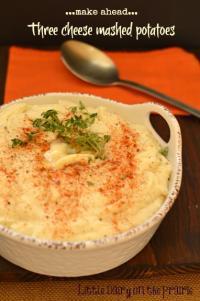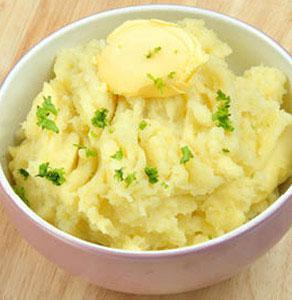The first image is the image on the left, the second image is the image on the right. Analyze the images presented: Is the assertion "An eating utensil is lifted above a bowl of food." valid? Answer yes or no. No. The first image is the image on the left, the second image is the image on the right. Given the left and right images, does the statement "There is a silvers spoon sitting in a white bowl of food." hold true? Answer yes or no. No. 